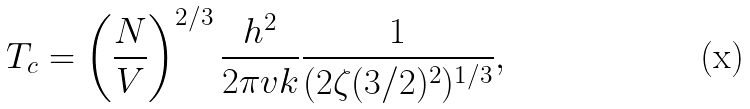Convert formula to latex. <formula><loc_0><loc_0><loc_500><loc_500>T _ { c } = \left ( \frac { N } { V } \right ) ^ { 2 / 3 } \frac { h ^ { 2 } } { 2 \pi v k } \frac { 1 } { ( 2 \zeta ( 3 / 2 ) ^ { 2 } ) ^ { 1 / 3 } } ,</formula> 